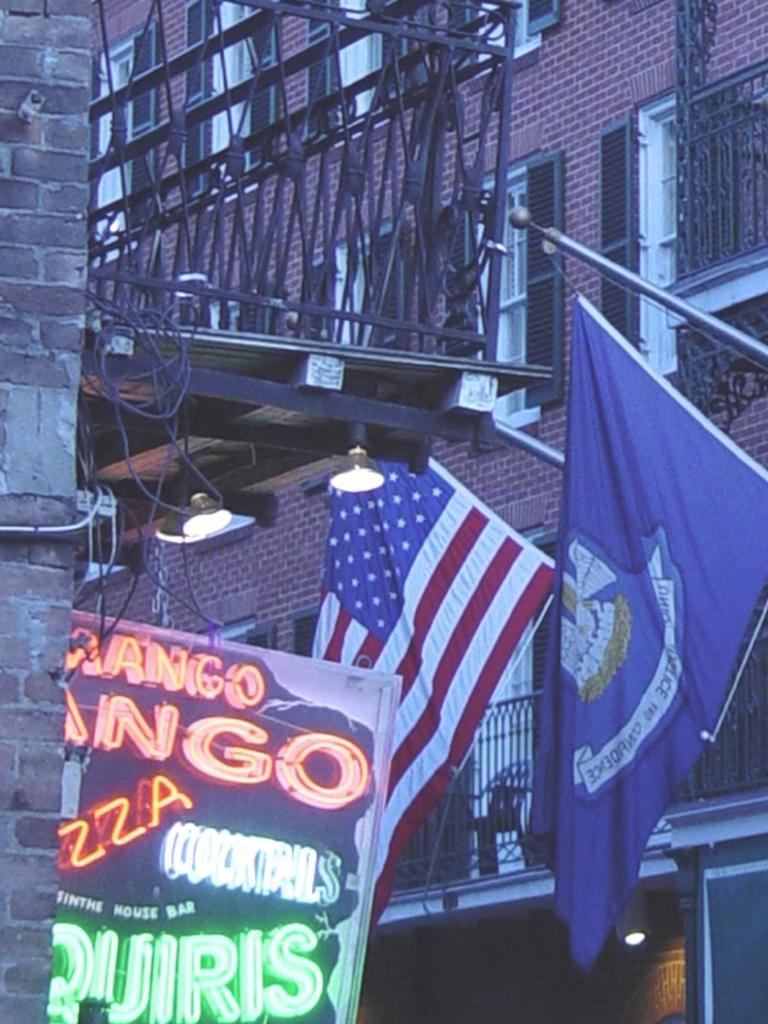In one or two sentences, can you explain what this image depicts? In this image, we can see a railings, building with windows, brick wall. Here we can see flags with rods, banner and lights. 